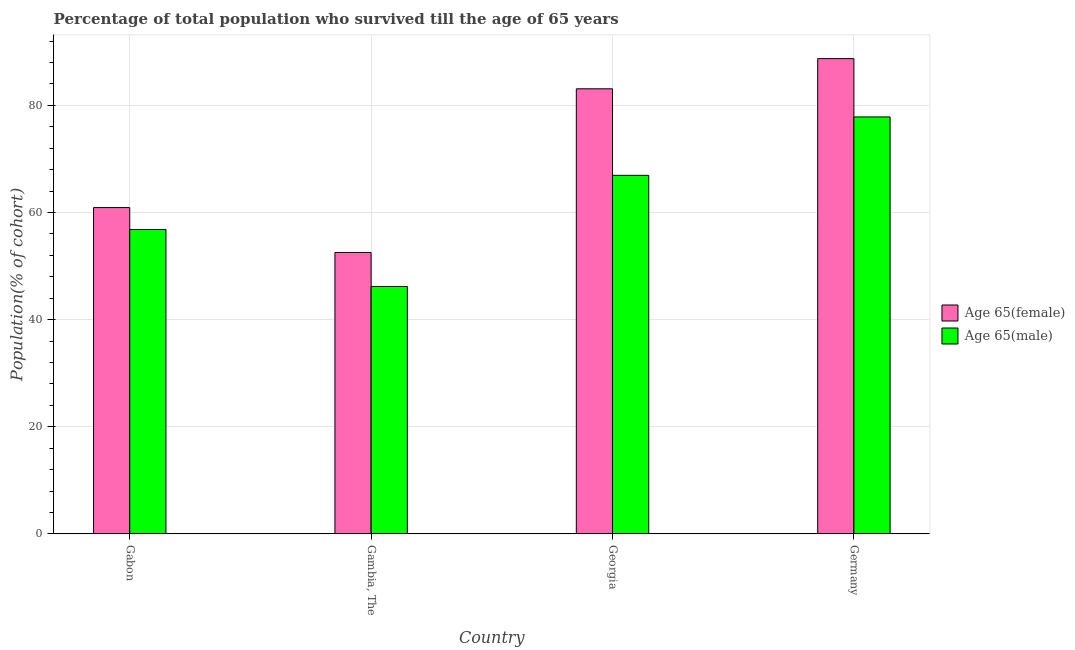Are the number of bars per tick equal to the number of legend labels?
Your answer should be compact. Yes. How many bars are there on the 1st tick from the left?
Your answer should be compact. 2. What is the label of the 2nd group of bars from the left?
Your response must be concise. Gambia, The. In how many cases, is the number of bars for a given country not equal to the number of legend labels?
Offer a very short reply. 0. What is the percentage of female population who survived till age of 65 in Gambia, The?
Give a very brief answer. 52.54. Across all countries, what is the maximum percentage of male population who survived till age of 65?
Provide a succinct answer. 77.84. Across all countries, what is the minimum percentage of female population who survived till age of 65?
Provide a succinct answer. 52.54. In which country was the percentage of female population who survived till age of 65 maximum?
Provide a succinct answer. Germany. In which country was the percentage of male population who survived till age of 65 minimum?
Give a very brief answer. Gambia, The. What is the total percentage of female population who survived till age of 65 in the graph?
Keep it short and to the point. 285.28. What is the difference between the percentage of female population who survived till age of 65 in Gambia, The and that in Georgia?
Your answer should be compact. -30.56. What is the difference between the percentage of male population who survived till age of 65 in Gambia, The and the percentage of female population who survived till age of 65 in Georgia?
Your answer should be compact. -36.91. What is the average percentage of female population who survived till age of 65 per country?
Offer a terse response. 71.32. What is the difference between the percentage of male population who survived till age of 65 and percentage of female population who survived till age of 65 in Gabon?
Offer a very short reply. -4.08. What is the ratio of the percentage of male population who survived till age of 65 in Georgia to that in Germany?
Give a very brief answer. 0.86. What is the difference between the highest and the second highest percentage of male population who survived till age of 65?
Provide a short and direct response. 10.9. What is the difference between the highest and the lowest percentage of female population who survived till age of 65?
Ensure brevity in your answer.  36.19. Is the sum of the percentage of male population who survived till age of 65 in Gambia, The and Georgia greater than the maximum percentage of female population who survived till age of 65 across all countries?
Make the answer very short. Yes. What does the 2nd bar from the left in Georgia represents?
Offer a very short reply. Age 65(male). What does the 1st bar from the right in Gambia, The represents?
Your answer should be compact. Age 65(male). Are the values on the major ticks of Y-axis written in scientific E-notation?
Offer a terse response. No. Does the graph contain any zero values?
Provide a succinct answer. No. Where does the legend appear in the graph?
Make the answer very short. Center right. What is the title of the graph?
Offer a terse response. Percentage of total population who survived till the age of 65 years. Does "Residents" appear as one of the legend labels in the graph?
Your response must be concise. No. What is the label or title of the X-axis?
Offer a terse response. Country. What is the label or title of the Y-axis?
Offer a terse response. Population(% of cohort). What is the Population(% of cohort) in Age 65(female) in Gabon?
Offer a very short reply. 60.92. What is the Population(% of cohort) in Age 65(male) in Gabon?
Your answer should be compact. 56.83. What is the Population(% of cohort) in Age 65(female) in Gambia, The?
Your answer should be very brief. 52.54. What is the Population(% of cohort) in Age 65(male) in Gambia, The?
Your answer should be very brief. 46.18. What is the Population(% of cohort) of Age 65(female) in Georgia?
Offer a terse response. 83.1. What is the Population(% of cohort) in Age 65(male) in Georgia?
Provide a short and direct response. 66.94. What is the Population(% of cohort) of Age 65(female) in Germany?
Your response must be concise. 88.73. What is the Population(% of cohort) of Age 65(male) in Germany?
Give a very brief answer. 77.84. Across all countries, what is the maximum Population(% of cohort) of Age 65(female)?
Offer a terse response. 88.73. Across all countries, what is the maximum Population(% of cohort) in Age 65(male)?
Your answer should be compact. 77.84. Across all countries, what is the minimum Population(% of cohort) of Age 65(female)?
Provide a succinct answer. 52.54. Across all countries, what is the minimum Population(% of cohort) of Age 65(male)?
Ensure brevity in your answer.  46.18. What is the total Population(% of cohort) of Age 65(female) in the graph?
Your response must be concise. 285.28. What is the total Population(% of cohort) in Age 65(male) in the graph?
Offer a very short reply. 247.8. What is the difference between the Population(% of cohort) in Age 65(female) in Gabon and that in Gambia, The?
Your response must be concise. 8.38. What is the difference between the Population(% of cohort) of Age 65(male) in Gabon and that in Gambia, The?
Make the answer very short. 10.65. What is the difference between the Population(% of cohort) of Age 65(female) in Gabon and that in Georgia?
Your answer should be very brief. -22.18. What is the difference between the Population(% of cohort) in Age 65(male) in Gabon and that in Georgia?
Your answer should be very brief. -10.11. What is the difference between the Population(% of cohort) of Age 65(female) in Gabon and that in Germany?
Your answer should be compact. -27.81. What is the difference between the Population(% of cohort) in Age 65(male) in Gabon and that in Germany?
Ensure brevity in your answer.  -21.01. What is the difference between the Population(% of cohort) of Age 65(female) in Gambia, The and that in Georgia?
Provide a succinct answer. -30.56. What is the difference between the Population(% of cohort) in Age 65(male) in Gambia, The and that in Georgia?
Your answer should be very brief. -20.76. What is the difference between the Population(% of cohort) in Age 65(female) in Gambia, The and that in Germany?
Provide a succinct answer. -36.19. What is the difference between the Population(% of cohort) in Age 65(male) in Gambia, The and that in Germany?
Your response must be concise. -31.66. What is the difference between the Population(% of cohort) in Age 65(female) in Georgia and that in Germany?
Keep it short and to the point. -5.63. What is the difference between the Population(% of cohort) in Age 65(male) in Georgia and that in Germany?
Offer a very short reply. -10.9. What is the difference between the Population(% of cohort) of Age 65(female) in Gabon and the Population(% of cohort) of Age 65(male) in Gambia, The?
Give a very brief answer. 14.73. What is the difference between the Population(% of cohort) in Age 65(female) in Gabon and the Population(% of cohort) in Age 65(male) in Georgia?
Keep it short and to the point. -6.02. What is the difference between the Population(% of cohort) of Age 65(female) in Gabon and the Population(% of cohort) of Age 65(male) in Germany?
Give a very brief answer. -16.92. What is the difference between the Population(% of cohort) of Age 65(female) in Gambia, The and the Population(% of cohort) of Age 65(male) in Georgia?
Your answer should be compact. -14.41. What is the difference between the Population(% of cohort) in Age 65(female) in Gambia, The and the Population(% of cohort) in Age 65(male) in Germany?
Your answer should be compact. -25.31. What is the difference between the Population(% of cohort) of Age 65(female) in Georgia and the Population(% of cohort) of Age 65(male) in Germany?
Your answer should be compact. 5.25. What is the average Population(% of cohort) in Age 65(female) per country?
Provide a short and direct response. 71.32. What is the average Population(% of cohort) of Age 65(male) per country?
Give a very brief answer. 61.95. What is the difference between the Population(% of cohort) of Age 65(female) and Population(% of cohort) of Age 65(male) in Gabon?
Your response must be concise. 4.08. What is the difference between the Population(% of cohort) in Age 65(female) and Population(% of cohort) in Age 65(male) in Gambia, The?
Offer a very short reply. 6.35. What is the difference between the Population(% of cohort) of Age 65(female) and Population(% of cohort) of Age 65(male) in Georgia?
Ensure brevity in your answer.  16.15. What is the difference between the Population(% of cohort) of Age 65(female) and Population(% of cohort) of Age 65(male) in Germany?
Offer a terse response. 10.89. What is the ratio of the Population(% of cohort) in Age 65(female) in Gabon to that in Gambia, The?
Your answer should be very brief. 1.16. What is the ratio of the Population(% of cohort) in Age 65(male) in Gabon to that in Gambia, The?
Provide a short and direct response. 1.23. What is the ratio of the Population(% of cohort) in Age 65(female) in Gabon to that in Georgia?
Your response must be concise. 0.73. What is the ratio of the Population(% of cohort) in Age 65(male) in Gabon to that in Georgia?
Offer a very short reply. 0.85. What is the ratio of the Population(% of cohort) in Age 65(female) in Gabon to that in Germany?
Make the answer very short. 0.69. What is the ratio of the Population(% of cohort) of Age 65(male) in Gabon to that in Germany?
Make the answer very short. 0.73. What is the ratio of the Population(% of cohort) of Age 65(female) in Gambia, The to that in Georgia?
Offer a very short reply. 0.63. What is the ratio of the Population(% of cohort) of Age 65(male) in Gambia, The to that in Georgia?
Your answer should be very brief. 0.69. What is the ratio of the Population(% of cohort) in Age 65(female) in Gambia, The to that in Germany?
Make the answer very short. 0.59. What is the ratio of the Population(% of cohort) in Age 65(male) in Gambia, The to that in Germany?
Your answer should be compact. 0.59. What is the ratio of the Population(% of cohort) in Age 65(female) in Georgia to that in Germany?
Provide a short and direct response. 0.94. What is the ratio of the Population(% of cohort) of Age 65(male) in Georgia to that in Germany?
Give a very brief answer. 0.86. What is the difference between the highest and the second highest Population(% of cohort) of Age 65(female)?
Ensure brevity in your answer.  5.63. What is the difference between the highest and the second highest Population(% of cohort) in Age 65(male)?
Provide a short and direct response. 10.9. What is the difference between the highest and the lowest Population(% of cohort) in Age 65(female)?
Offer a very short reply. 36.19. What is the difference between the highest and the lowest Population(% of cohort) of Age 65(male)?
Provide a succinct answer. 31.66. 